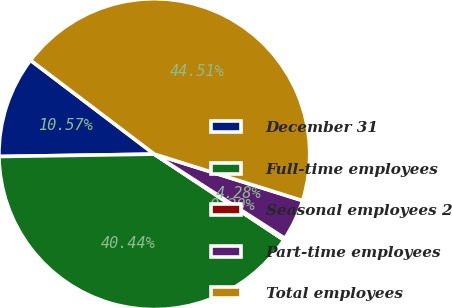Convert chart to OTSL. <chart><loc_0><loc_0><loc_500><loc_500><pie_chart><fcel>December 31<fcel>Full-time employees<fcel>Seasonal employees 2<fcel>Part-time employees<fcel>Total employees<nl><fcel>10.57%<fcel>40.44%<fcel>0.2%<fcel>4.28%<fcel>44.51%<nl></chart> 